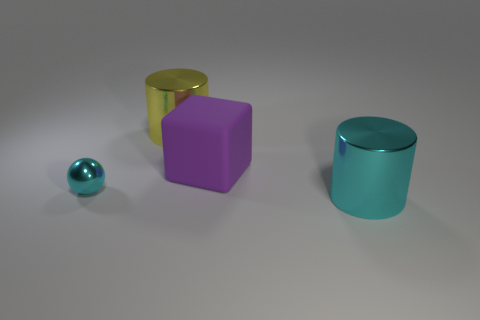Is there any other thing that has the same material as the large purple block?
Keep it short and to the point. No. There is another thing that is the same shape as the big cyan metal thing; what size is it?
Your answer should be very brief. Large. How many cylinders are either large yellow things or gray things?
Make the answer very short. 1. What material is the large object that is the same color as the small sphere?
Your answer should be very brief. Metal. Is the number of large cyan objects left of the yellow metallic cylinder less than the number of large yellow shiny things that are in front of the big cyan object?
Offer a very short reply. No. How many things are either objects that are in front of the large cube or large purple blocks?
Provide a short and direct response. 3. There is a big metal thing in front of the cyan object that is left of the big yellow cylinder; what is its shape?
Give a very brief answer. Cylinder. Are there any other things that have the same size as the yellow shiny thing?
Give a very brief answer. Yes. Are there more cubes than tiny green rubber cubes?
Keep it short and to the point. Yes. There is a metal cylinder right of the large yellow cylinder; does it have the same size as the cylinder behind the cyan metallic cylinder?
Ensure brevity in your answer.  Yes. 